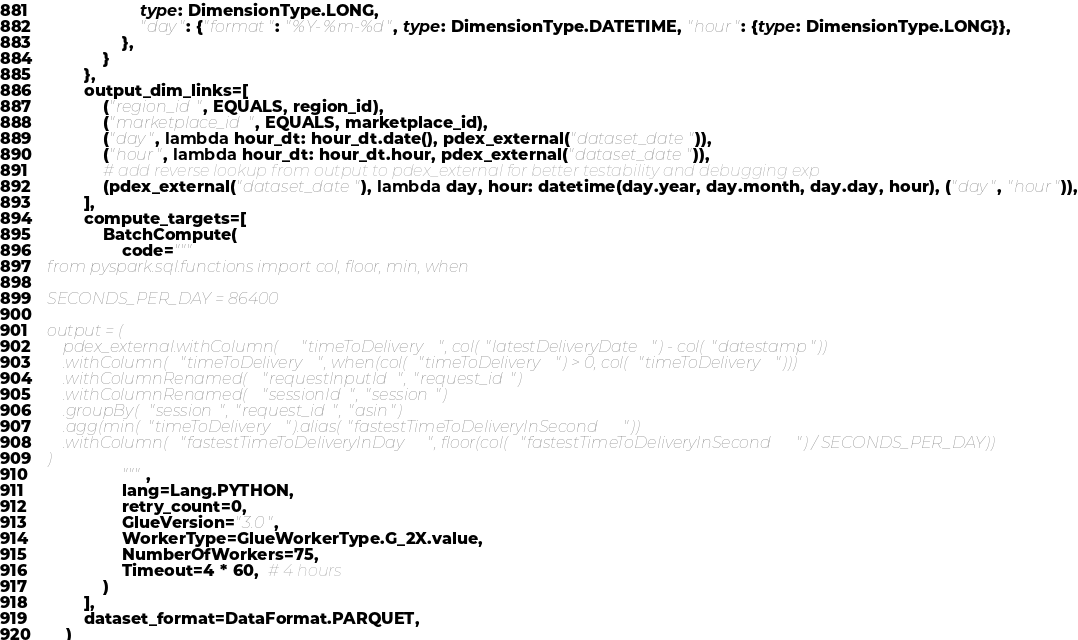Convert code to text. <code><loc_0><loc_0><loc_500><loc_500><_Python_>                    type: DimensionType.LONG,
                    "day": {"format": "%Y-%m-%d", type: DimensionType.DATETIME, "hour": {type: DimensionType.LONG}},
                },
            }
        },
        output_dim_links=[
            ("region_id", EQUALS, region_id),
            ("marketplace_id", EQUALS, marketplace_id),
            ("day", lambda hour_dt: hour_dt.date(), pdex_external("dataset_date")),
            ("hour", lambda hour_dt: hour_dt.hour, pdex_external("dataset_date")),
            # add reverse lookup from output to pdex_external for better testability and debugging exp
            (pdex_external("dataset_date"), lambda day, hour: datetime(day.year, day.month, day.day, hour), ("day", "hour")),
        ],
        compute_targets=[
            BatchCompute(
                code="""
from pyspark.sql.functions import col, floor, min, when

SECONDS_PER_DAY = 86400

output = (
    pdex_external.withColumn("timeToDelivery", col("latestDeliveryDate") - col("datestamp"))
    .withColumn("timeToDelivery", when(col("timeToDelivery") > 0, col("timeToDelivery")))
    .withColumnRenamed("requestInputId", "request_id")
    .withColumnRenamed("sessionId", "session")
    .groupBy("session", "request_id", "asin")
    .agg(min("timeToDelivery").alias("fastestTimeToDeliveryInSecond"))
    .withColumn("fastestTimeToDeliveryInDay", floor(col("fastestTimeToDeliveryInSecond") / SECONDS_PER_DAY))
)
                """,
                lang=Lang.PYTHON,
                retry_count=0,
                GlueVersion="3.0",
                WorkerType=GlueWorkerType.G_2X.value,
                NumberOfWorkers=75,
                Timeout=4 * 60,  # 4 hours
            )
        ],
        dataset_format=DataFormat.PARQUET,
    )
</code> 